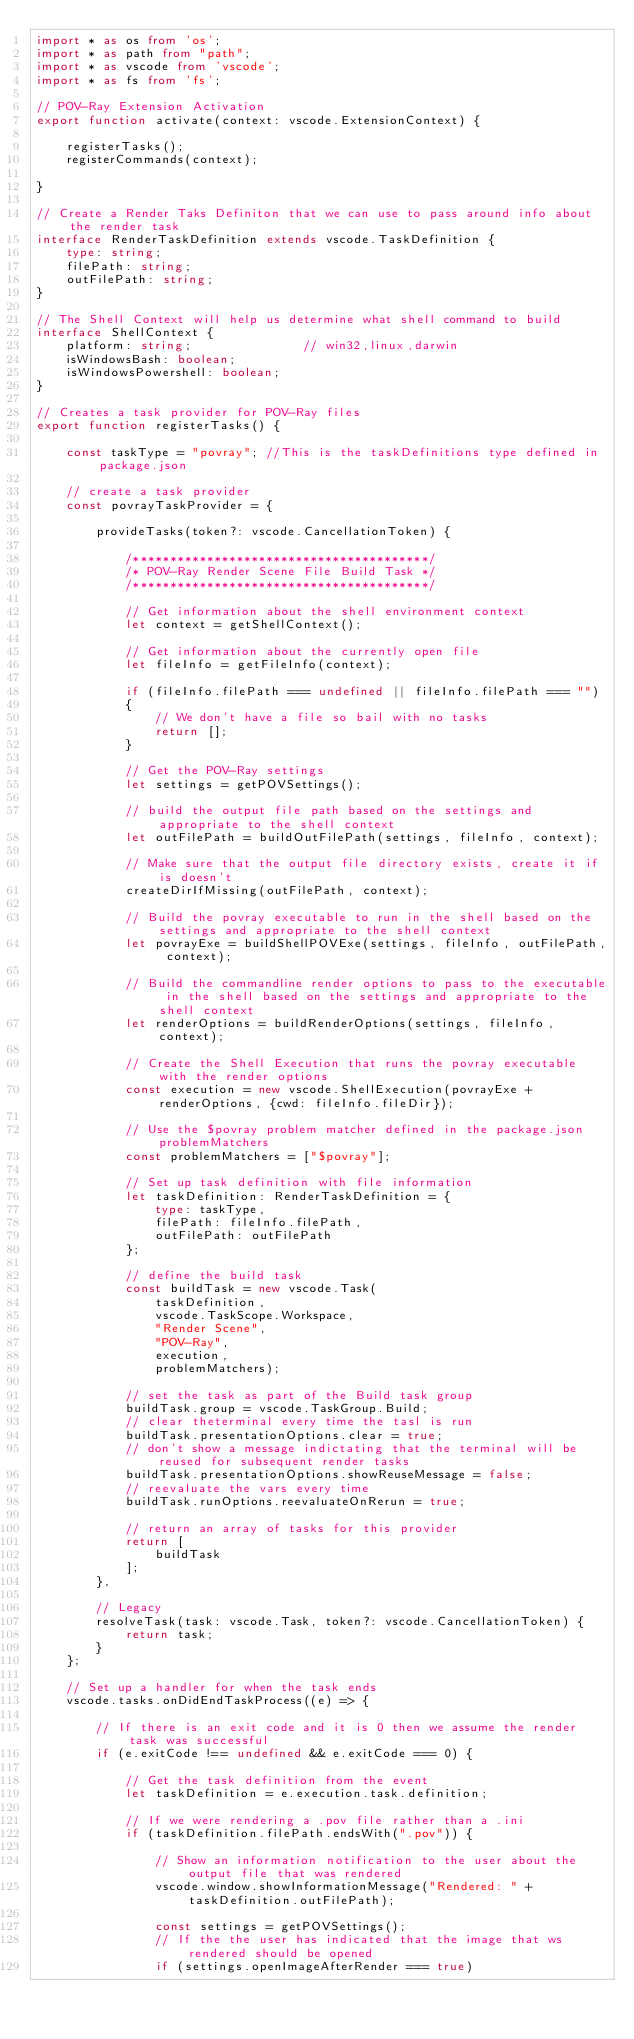Convert code to text. <code><loc_0><loc_0><loc_500><loc_500><_TypeScript_>import * as os from 'os';
import * as path from "path";
import * as vscode from 'vscode';
import * as fs from 'fs';

// POV-Ray Extension Activation
export function activate(context: vscode.ExtensionContext) {

    registerTasks();
    registerCommands(context);

}

// Create a Render Taks Definiton that we can use to pass around info about the render task
interface RenderTaskDefinition extends vscode.TaskDefinition {
    type: string;
    filePath: string;
    outFilePath: string;
}

// The Shell Context will help us determine what shell command to build
interface ShellContext {
    platform: string;               // win32,linux,darwin
    isWindowsBash: boolean;
    isWindowsPowershell: boolean;
}

// Creates a task provider for POV-Ray files
export function registerTasks() {

    const taskType = "povray"; //This is the taskDefinitions type defined in package.json
    
    // create a task provider
    const povrayTaskProvider = {

        provideTasks(token?: vscode.CancellationToken) {

            /****************************************/
            /* POV-Ray Render Scene File Build Task */
            /****************************************/

            // Get information about the shell environment context
            let context = getShellContext();

            // Get information about the currently open file
            let fileInfo = getFileInfo(context);

            if (fileInfo.filePath === undefined || fileInfo.filePath === "")
            {
                // We don't have a file so bail with no tasks
                return [];
            }

            // Get the POV-Ray settings
            let settings = getPOVSettings();

            // build the output file path based on the settings and appropriate to the shell context
            let outFilePath = buildOutFilePath(settings, fileInfo, context);

            // Make sure that the output file directory exists, create it if is doesn't
            createDirIfMissing(outFilePath, context);

            // Build the povray executable to run in the shell based on the settings and appropriate to the shell context
            let povrayExe = buildShellPOVExe(settings, fileInfo, outFilePath, context);

            // Build the commandline render options to pass to the executable in the shell based on the settings and appropriate to the shell context
            let renderOptions = buildRenderOptions(settings, fileInfo, context);
            
            // Create the Shell Execution that runs the povray executable with the render options
            const execution = new vscode.ShellExecution(povrayExe + renderOptions, {cwd: fileInfo.fileDir});

            // Use the $povray problem matcher defined in the package.json problemMatchers
            const problemMatchers = ["$povray"];

            // Set up task definition with file information
            let taskDefinition: RenderTaskDefinition = {
                type: taskType,
                filePath: fileInfo.filePath,
                outFilePath: outFilePath
            };

            // define the build task
            const buildTask = new vscode.Task(
                taskDefinition, 
                vscode.TaskScope.Workspace, 
                "Render Scene", 
                "POV-Ray", 
                execution, 
                problemMatchers);

            // set the task as part of the Build task group    
            buildTask.group = vscode.TaskGroup.Build;
            // clear theterminal every time the tasl is run
            buildTask.presentationOptions.clear = true;
            // don't show a message indictating that the terminal will be reused for subsequent render tasks
            buildTask.presentationOptions.showReuseMessage = false;
            // reevaluate the vars every time
            buildTask.runOptions.reevaluateOnRerun = true;

            // return an array of tasks for this provider
            return [
                buildTask
            ];
        },

        // Legacy
        resolveTask(task: vscode.Task, token?: vscode.CancellationToken) {
            return task;
        }
    };

    // Set up a handler for when the task ends
    vscode.tasks.onDidEndTaskProcess((e) => {

        // If there is an exit code and it is 0 then we assume the render task was successful
        if (e.exitCode !== undefined && e.exitCode === 0) {
            
            // Get the task definition from the event
            let taskDefinition = e.execution.task.definition;
            
            // If we were rendering a .pov file rather than a .ini
            if (taskDefinition.filePath.endsWith(".pov")) {

                // Show an information notification to the user about the output file that was rendered
                vscode.window.showInformationMessage("Rendered: " + taskDefinition.outFilePath);

                const settings = getPOVSettings();
                // If the the user has indicated that the image that ws rendered should be opened
                if (settings.openImageAfterRender === true)</code> 